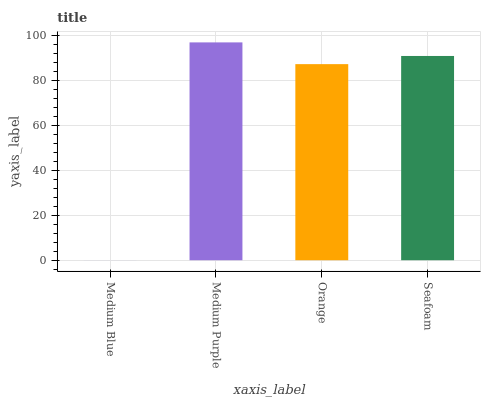Is Orange the minimum?
Answer yes or no. No. Is Orange the maximum?
Answer yes or no. No. Is Medium Purple greater than Orange?
Answer yes or no. Yes. Is Orange less than Medium Purple?
Answer yes or no. Yes. Is Orange greater than Medium Purple?
Answer yes or no. No. Is Medium Purple less than Orange?
Answer yes or no. No. Is Seafoam the high median?
Answer yes or no. Yes. Is Orange the low median?
Answer yes or no. Yes. Is Medium Blue the high median?
Answer yes or no. No. Is Medium Purple the low median?
Answer yes or no. No. 